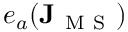<formula> <loc_0><loc_0><loc_500><loc_500>e _ { a } ( J _ { M S } )</formula> 